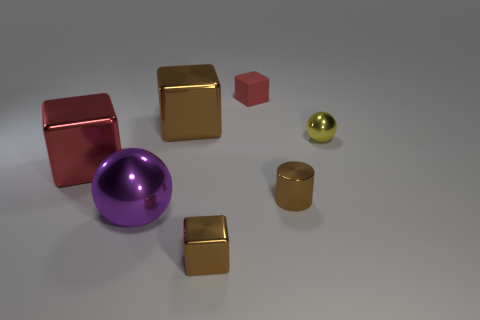Add 1 large shiny spheres. How many objects exist? 8 Subtract all blocks. How many objects are left? 3 Subtract all small cyan objects. Subtract all red things. How many objects are left? 5 Add 4 metal things. How many metal things are left? 10 Add 4 green metallic cylinders. How many green metallic cylinders exist? 4 Subtract 0 cyan cylinders. How many objects are left? 7 